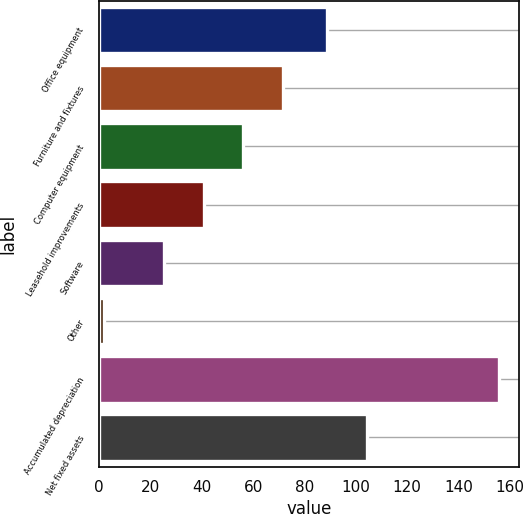Convert chart. <chart><loc_0><loc_0><loc_500><loc_500><bar_chart><fcel>Office equipment<fcel>Furniture and fixtures<fcel>Computer equipment<fcel>Leasehold improvements<fcel>Software<fcel>Other<fcel>Accumulated depreciation<fcel>Net fixed assets<nl><fcel>88.8<fcel>71.53<fcel>56.12<fcel>40.71<fcel>25.3<fcel>1.8<fcel>155.9<fcel>104.21<nl></chart> 